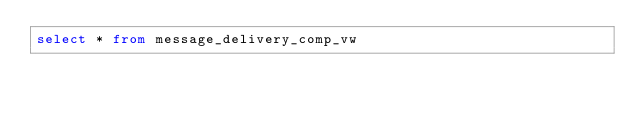<code> <loc_0><loc_0><loc_500><loc_500><_SQL_>select * from message_delivery_comp_vw</code> 